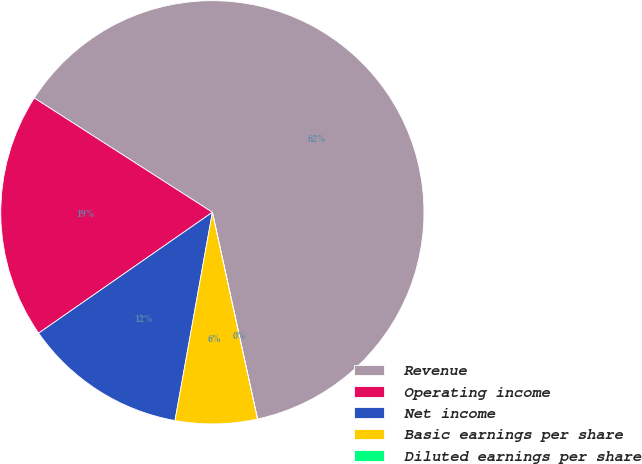Convert chart. <chart><loc_0><loc_0><loc_500><loc_500><pie_chart><fcel>Revenue<fcel>Operating income<fcel>Net income<fcel>Basic earnings per share<fcel>Diluted earnings per share<nl><fcel>62.5%<fcel>18.75%<fcel>12.5%<fcel>6.25%<fcel>0.0%<nl></chart> 